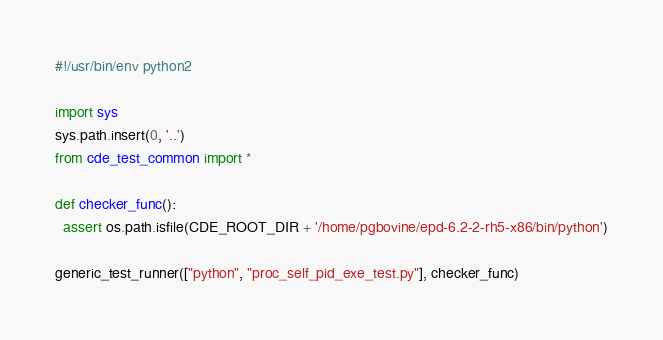<code> <loc_0><loc_0><loc_500><loc_500><_Python_>#!/usr/bin/env python2

import sys
sys.path.insert(0, '..')
from cde_test_common import *

def checker_func():
  assert os.path.isfile(CDE_ROOT_DIR + '/home/pgbovine/epd-6.2-2-rh5-x86/bin/python')

generic_test_runner(["python", "proc_self_pid_exe_test.py"], checker_func)
</code> 